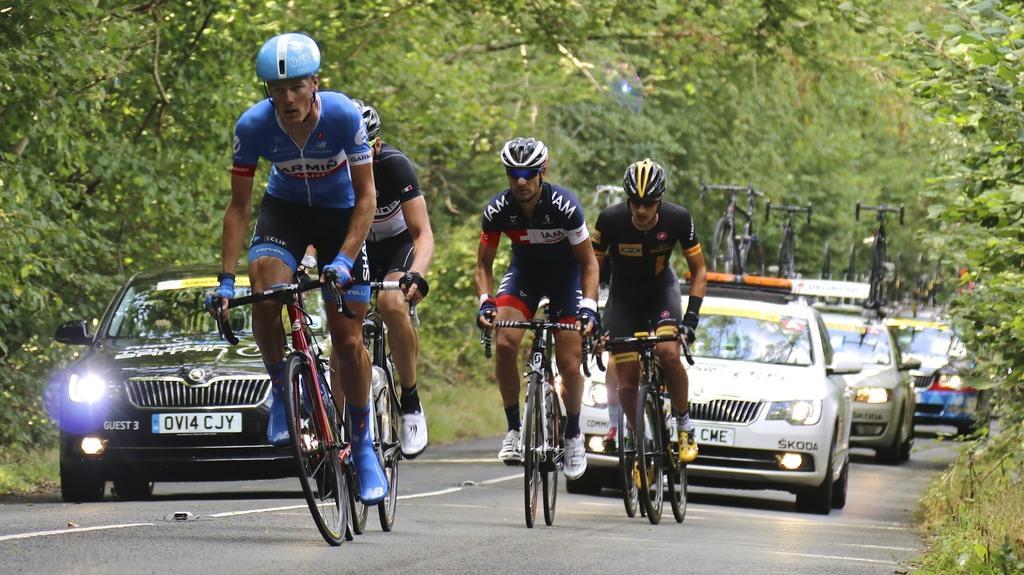Could you give a brief overview of what you see in this image? In this image a group of people are cycling on the road ,And a few cars are following the cycling persons. 